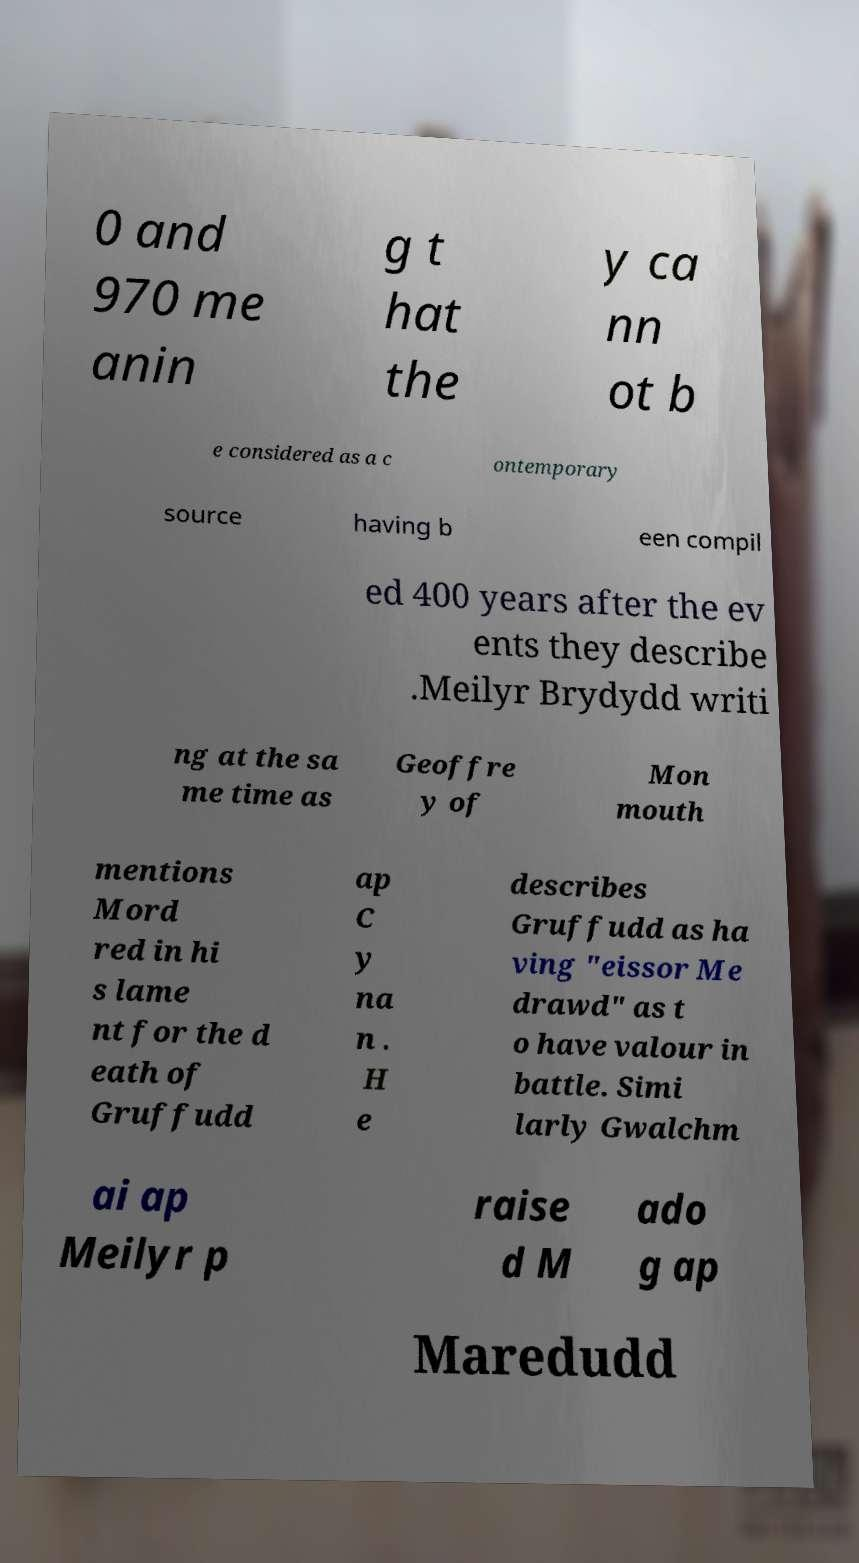Could you assist in decoding the text presented in this image and type it out clearly? 0 and 970 me anin g t hat the y ca nn ot b e considered as a c ontemporary source having b een compil ed 400 years after the ev ents they describe .Meilyr Brydydd writi ng at the sa me time as Geoffre y of Mon mouth mentions Mord red in hi s lame nt for the d eath of Gruffudd ap C y na n . H e describes Gruffudd as ha ving "eissor Me drawd" as t o have valour in battle. Simi larly Gwalchm ai ap Meilyr p raise d M ado g ap Maredudd 